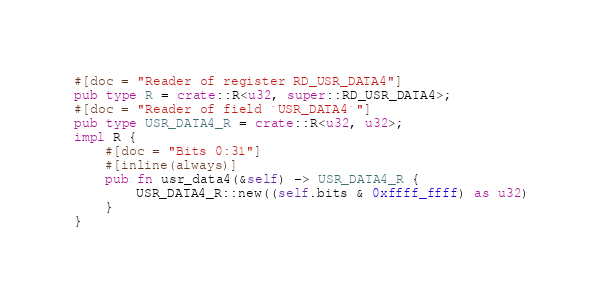<code> <loc_0><loc_0><loc_500><loc_500><_Rust_>#[doc = "Reader of register RD_USR_DATA4"]
pub type R = crate::R<u32, super::RD_USR_DATA4>;
#[doc = "Reader of field `USR_DATA4`"]
pub type USR_DATA4_R = crate::R<u32, u32>;
impl R {
    #[doc = "Bits 0:31"]
    #[inline(always)]
    pub fn usr_data4(&self) -> USR_DATA4_R {
        USR_DATA4_R::new((self.bits & 0xffff_ffff) as u32)
    }
}
</code> 